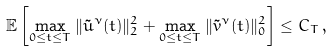<formula> <loc_0><loc_0><loc_500><loc_500>\mathbb { E } \left [ \max _ { 0 \leq t \leq T } \| \tilde { u } ^ { \nu } ( t ) \| _ { 2 } ^ { 2 } + \max _ { 0 \leq t \leq T } \| \tilde { v } ^ { \nu } ( t ) \| ^ { 2 } _ { 0 } \right ] \leq C _ { T } \, ,</formula> 